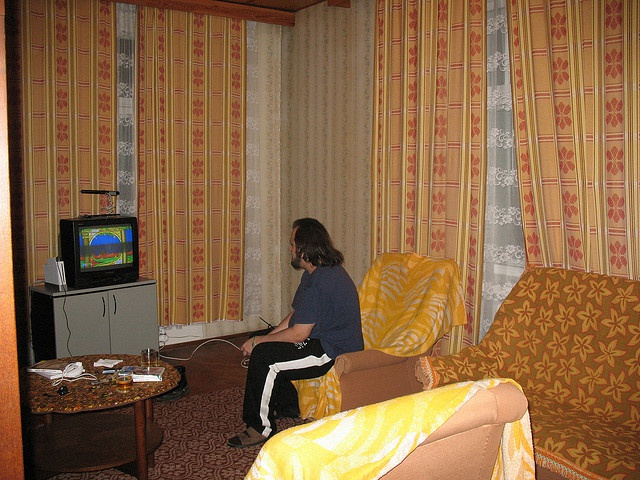Describe the objects in this image and their specific colors. I can see couch in brown and maroon tones, chair in brown, khaki, tan, and ivory tones, couch in brown, khaki, tan, and beige tones, chair in brown, olive, orange, gray, and tan tones, and people in brown, black, and maroon tones in this image. 